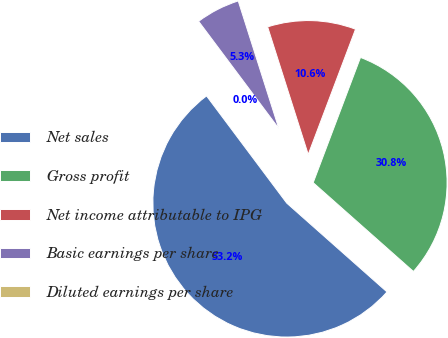Convert chart to OTSL. <chart><loc_0><loc_0><loc_500><loc_500><pie_chart><fcel>Net sales<fcel>Gross profit<fcel>Net income attributable to IPG<fcel>Basic earnings per share<fcel>Diluted earnings per share<nl><fcel>53.24%<fcel>30.79%<fcel>10.65%<fcel>5.32%<fcel>0.0%<nl></chart> 